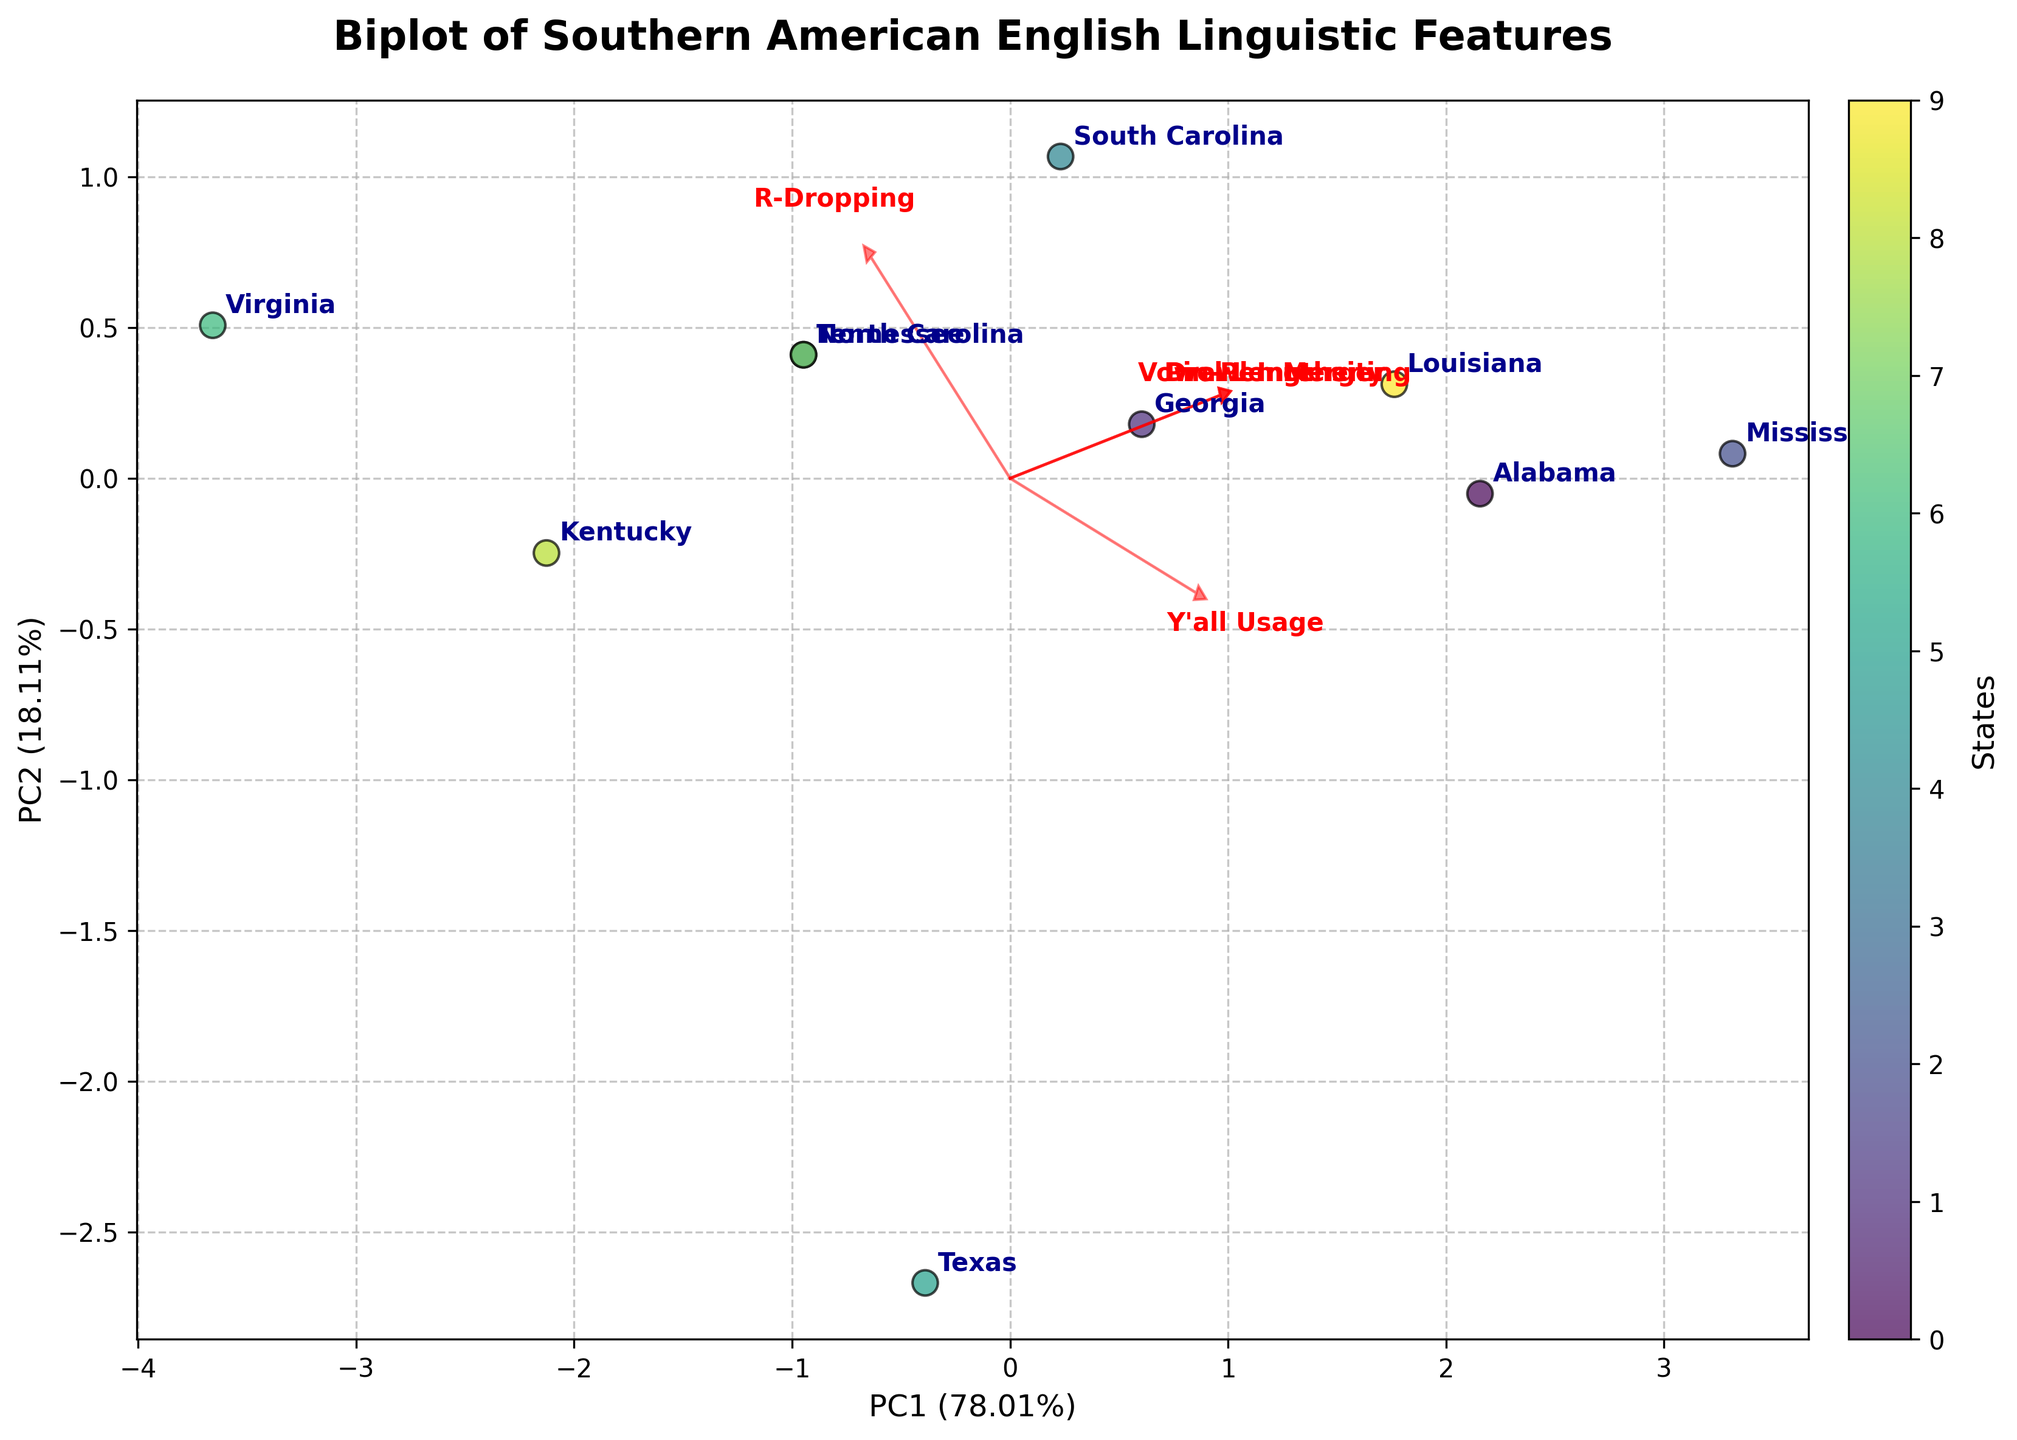What is the title of the plot? The title of the plot is typically placed at the top of the figure for easy identification. It states what the plot is about.
Answer: Biplot of Southern American English Linguistic Features How are the axes labeled in the plot? Axes labels are usually placed next to the axes to indicate what each axis represents. PC1 and PC2, along with percentage variance explained, are standard in PCA biplots.
Answer: PC1 and PC2 Which state is closest to the origin (0,0) in the plot? The origin (0,0) in a biplot represents the average values for PC1 and PC2. The state closest to this point can be identified visually by looking at the scatter points nearest to the center.
Answer: Virginia Which state has the highest "Drawl Intensity"? In a biplot, linguistic features can be identified by following the direction of loading vectors. The state furthest in the direction of the "Drawl Intensity" vector will have the highest value for that feature.
Answer: Mississippi Which two states have similar coordinates in the biplot? Similar coordinates mean data points that are close together in the plot. Look for scatter points that are almost overlapping or very near to each other.
Answer: North Carolina and Tennessee How many states are represented in the plot? Each data point represents a different state. By counting the labeled points (states) in the plot, we can determine the total number of states represented.
Answer: 10 states Which feature vector has the longest arrow among the loading vectors? The length of the arrow indicates the contribution (or loading) of a feature to the principal components. The longest arrow corresponds to the feature with the largest loading.
Answer: Vowel Lengthening Are there any states with overlapping data points, and if so, which ones? Overlapping data points are identified by labels that are very close to or on top of each other within the plot. Look for visually overlapping or adjoining points.
Answer: North Carolina and Tennessee have closely overlapping points Which state has a high "R-Dropping" but low "Vowel Lengthening"? Identify the state's scatter point that aligns strongly in the direction of the "R-Dropping" vector but away from the "Vowel Lengthening" vector. The state closest to the vector of "R-Dropping" but distant from "Vowel Lengthening" vector direction is the answer.
Answer: Virginia Is "Y'all Usage" more closely associated with "Drawl Intensity" or "Pin-Pen Merger"? Comparing the directions of the loading vectors for "Y'all Usage" with those for "Drawl Intensity" and "Pin-Pen Merger," the attribute that is aligned closest to "Y'all Usage" indicates the closer association.
Answer: Drawl Intensity 